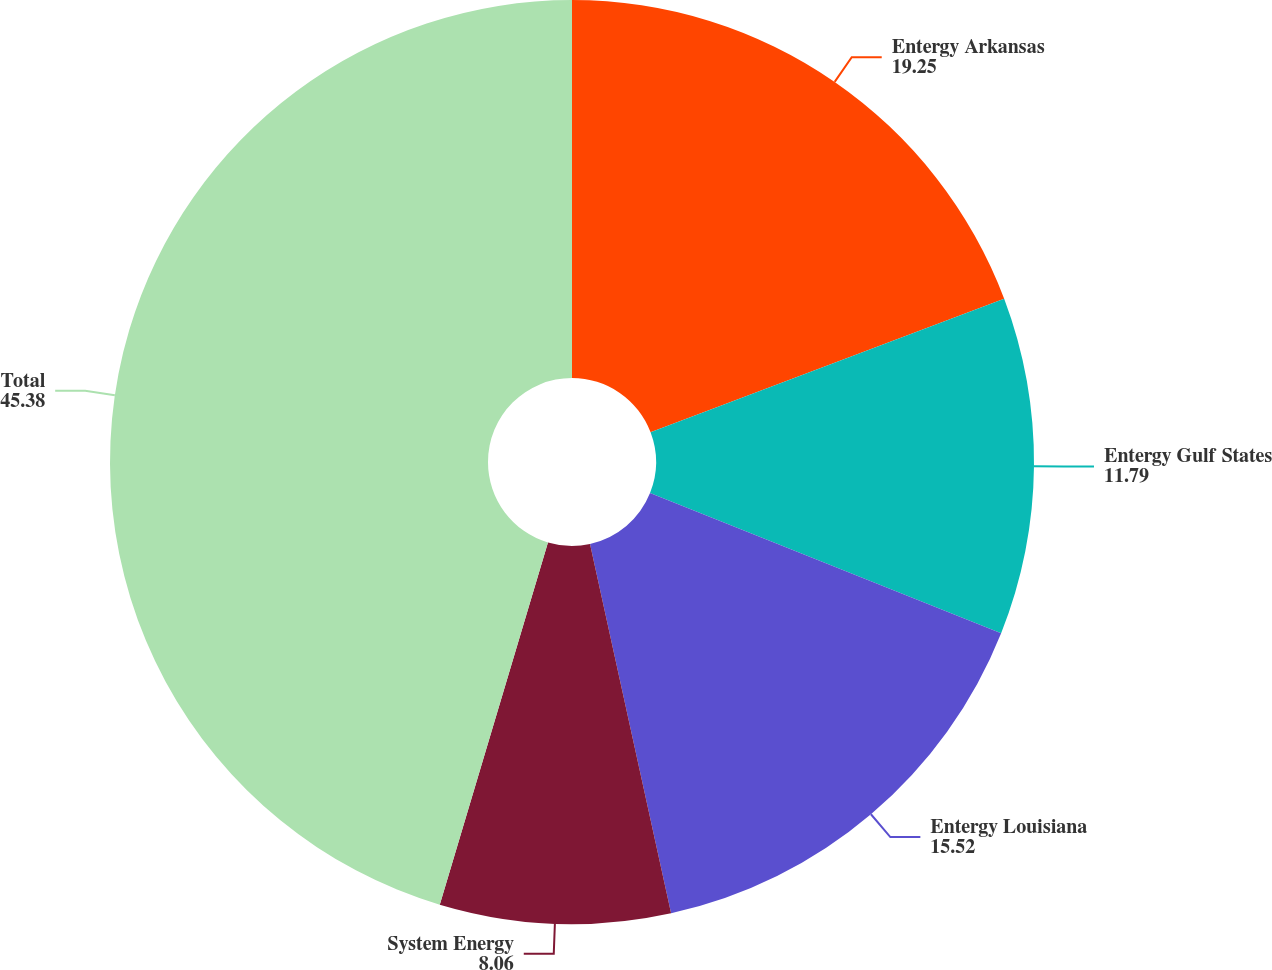<chart> <loc_0><loc_0><loc_500><loc_500><pie_chart><fcel>Entergy Arkansas<fcel>Entergy Gulf States<fcel>Entergy Louisiana<fcel>System Energy<fcel>Total<nl><fcel>19.25%<fcel>11.79%<fcel>15.52%<fcel>8.06%<fcel>45.38%<nl></chart> 